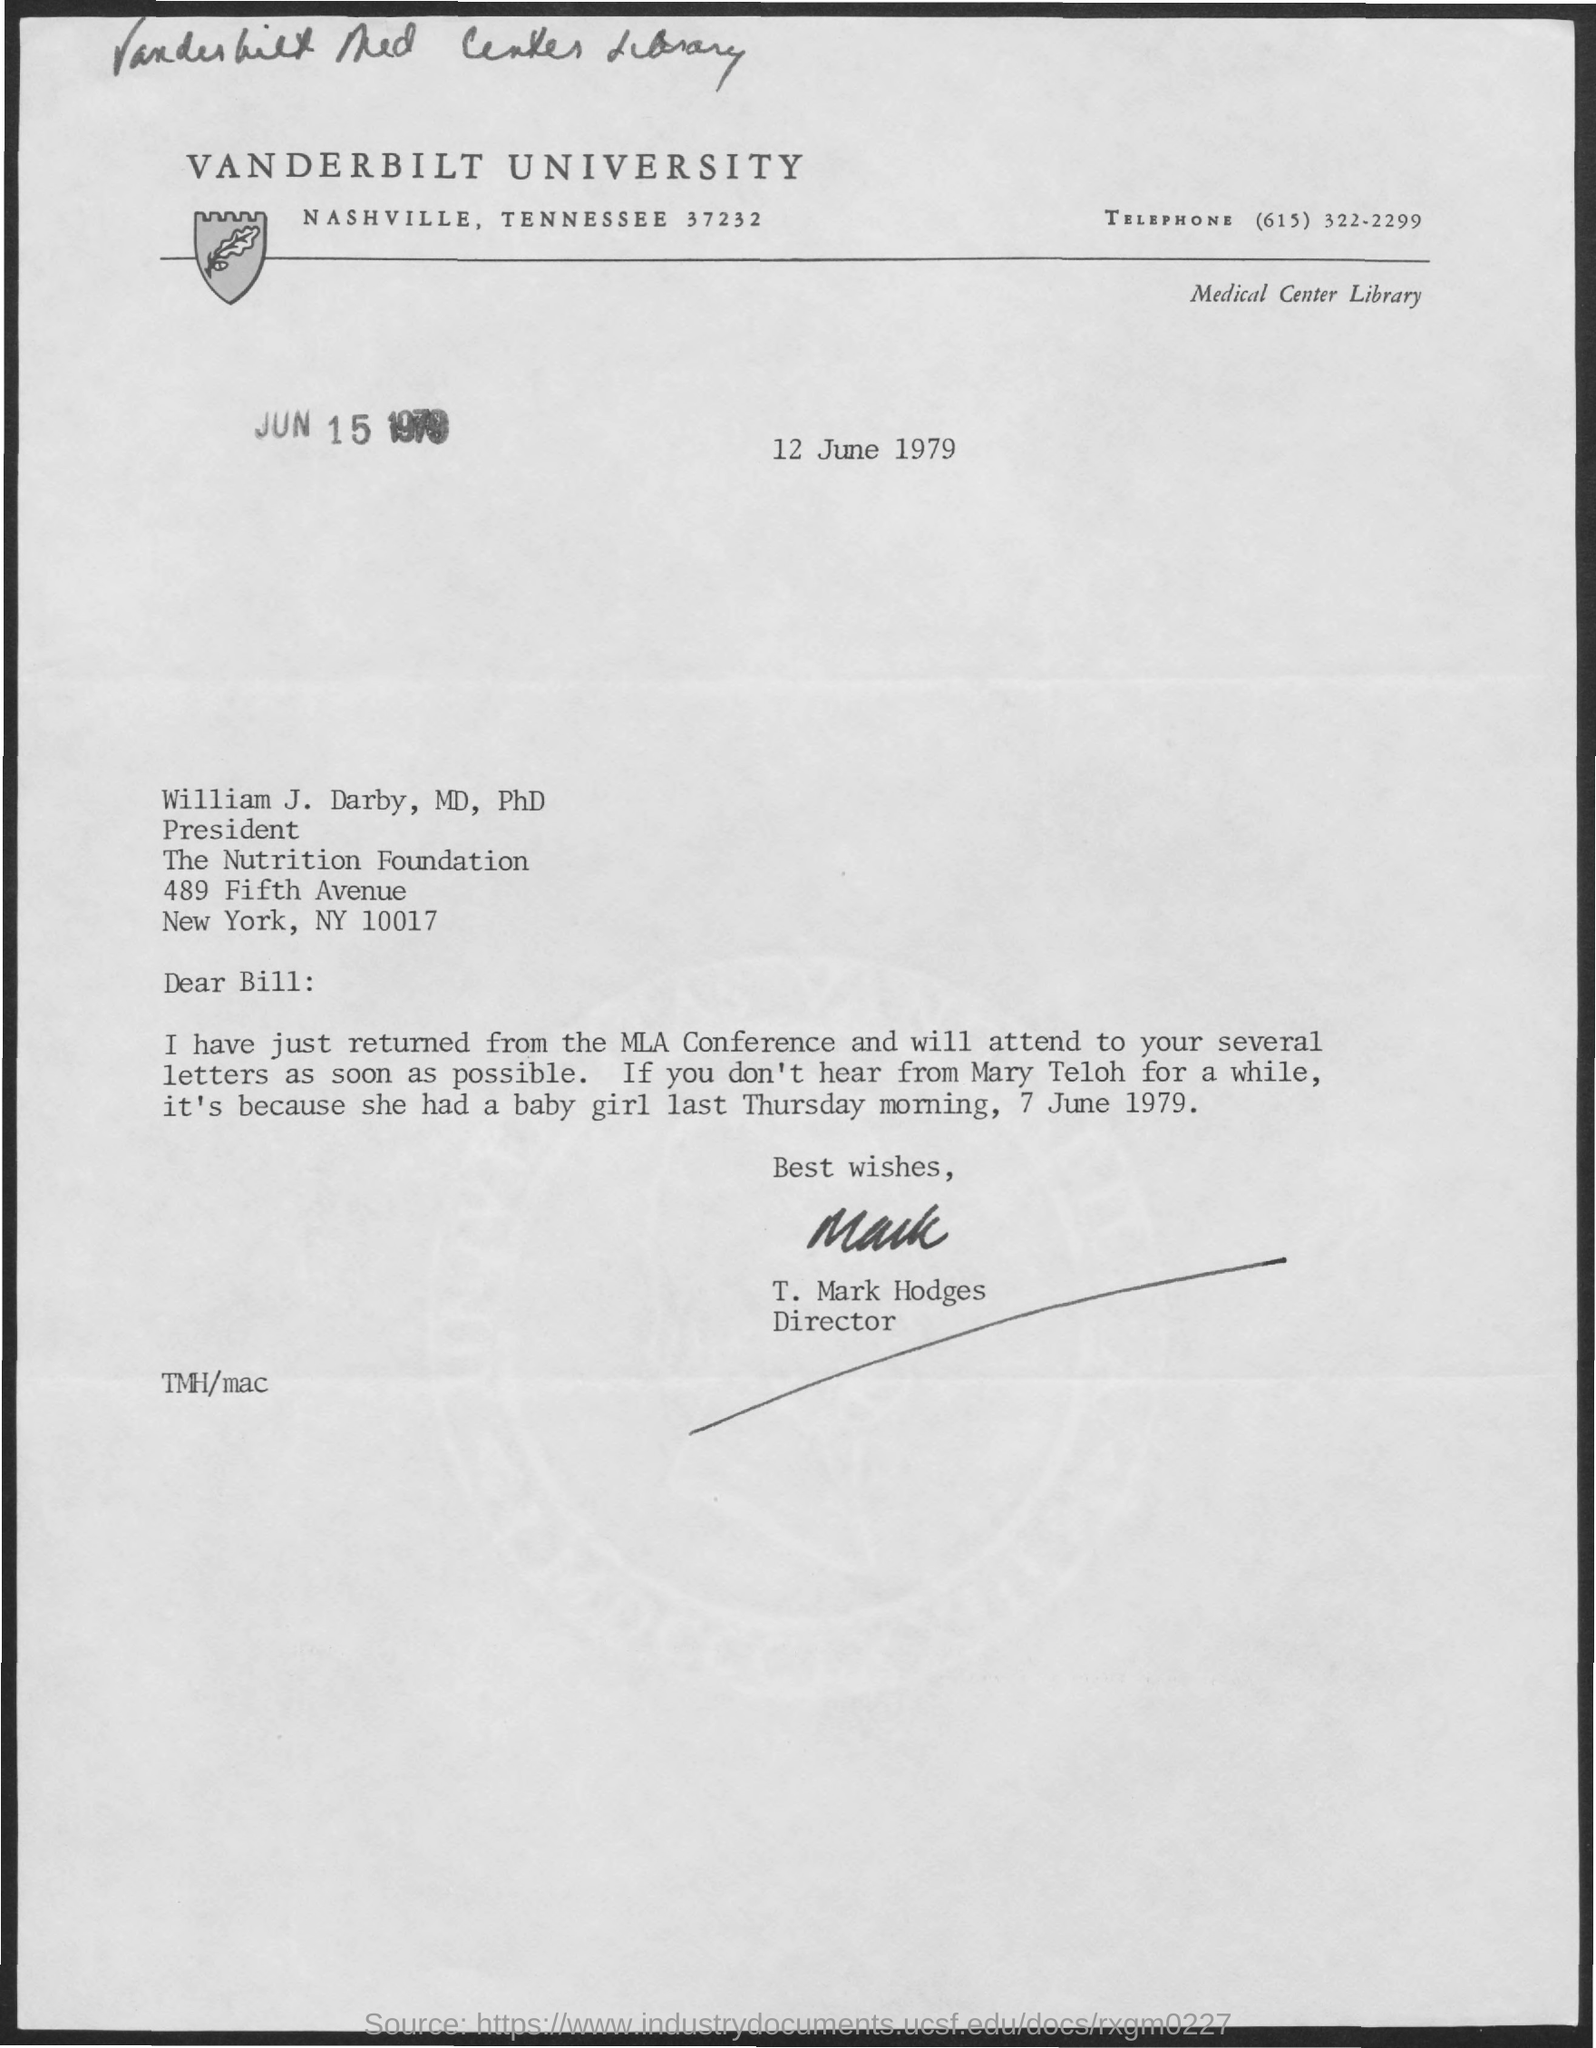Highlight a few significant elements in this photo. The letter was sent to William J. Darby. The telephone number mentioned in the given page is (615) 322-2299. The name of the university mentioned in the given form is Vanderbilt University. The signature at the bottom of the letter was that of T. Mark Hodges. Mr. T. Mark Hodges' designation is Director. 